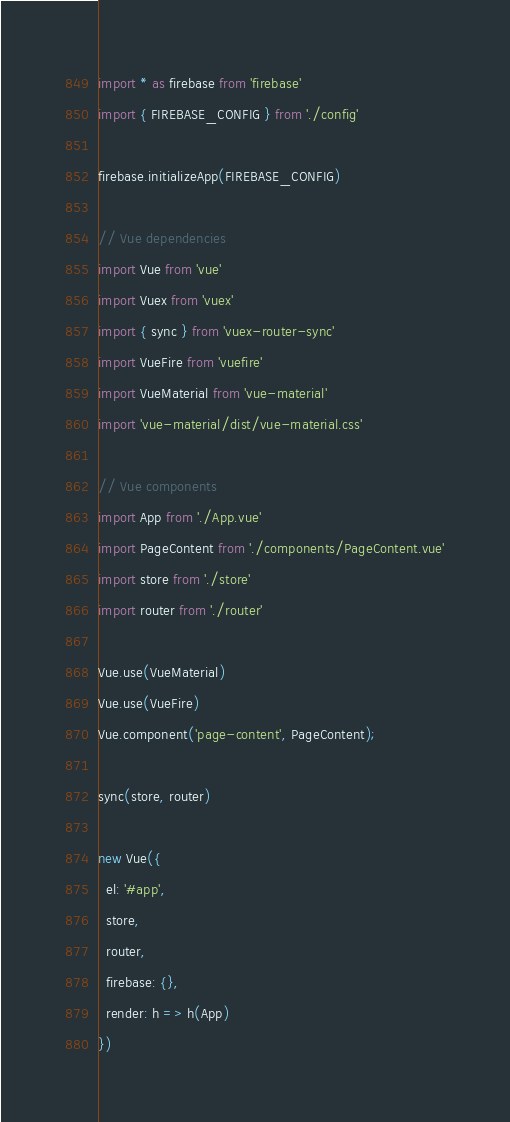Convert code to text. <code><loc_0><loc_0><loc_500><loc_500><_JavaScript_>import * as firebase from 'firebase'
import { FIREBASE_CONFIG } from './config'

firebase.initializeApp(FIREBASE_CONFIG)

// Vue dependencies
import Vue from 'vue'
import Vuex from 'vuex'
import { sync } from 'vuex-router-sync'
import VueFire from 'vuefire'
import VueMaterial from 'vue-material'
import 'vue-material/dist/vue-material.css'

// Vue components
import App from './App.vue'
import PageContent from './components/PageContent.vue'
import store from './store'
import router from './router'

Vue.use(VueMaterial)
Vue.use(VueFire)
Vue.component('page-content', PageContent);

sync(store, router)

new Vue({
  el: '#app',
  store,
  router,
  firebase: {},
  render: h => h(App)
})
</code> 